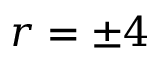Convert formula to latex. <formula><loc_0><loc_0><loc_500><loc_500>r = \pm 4</formula> 